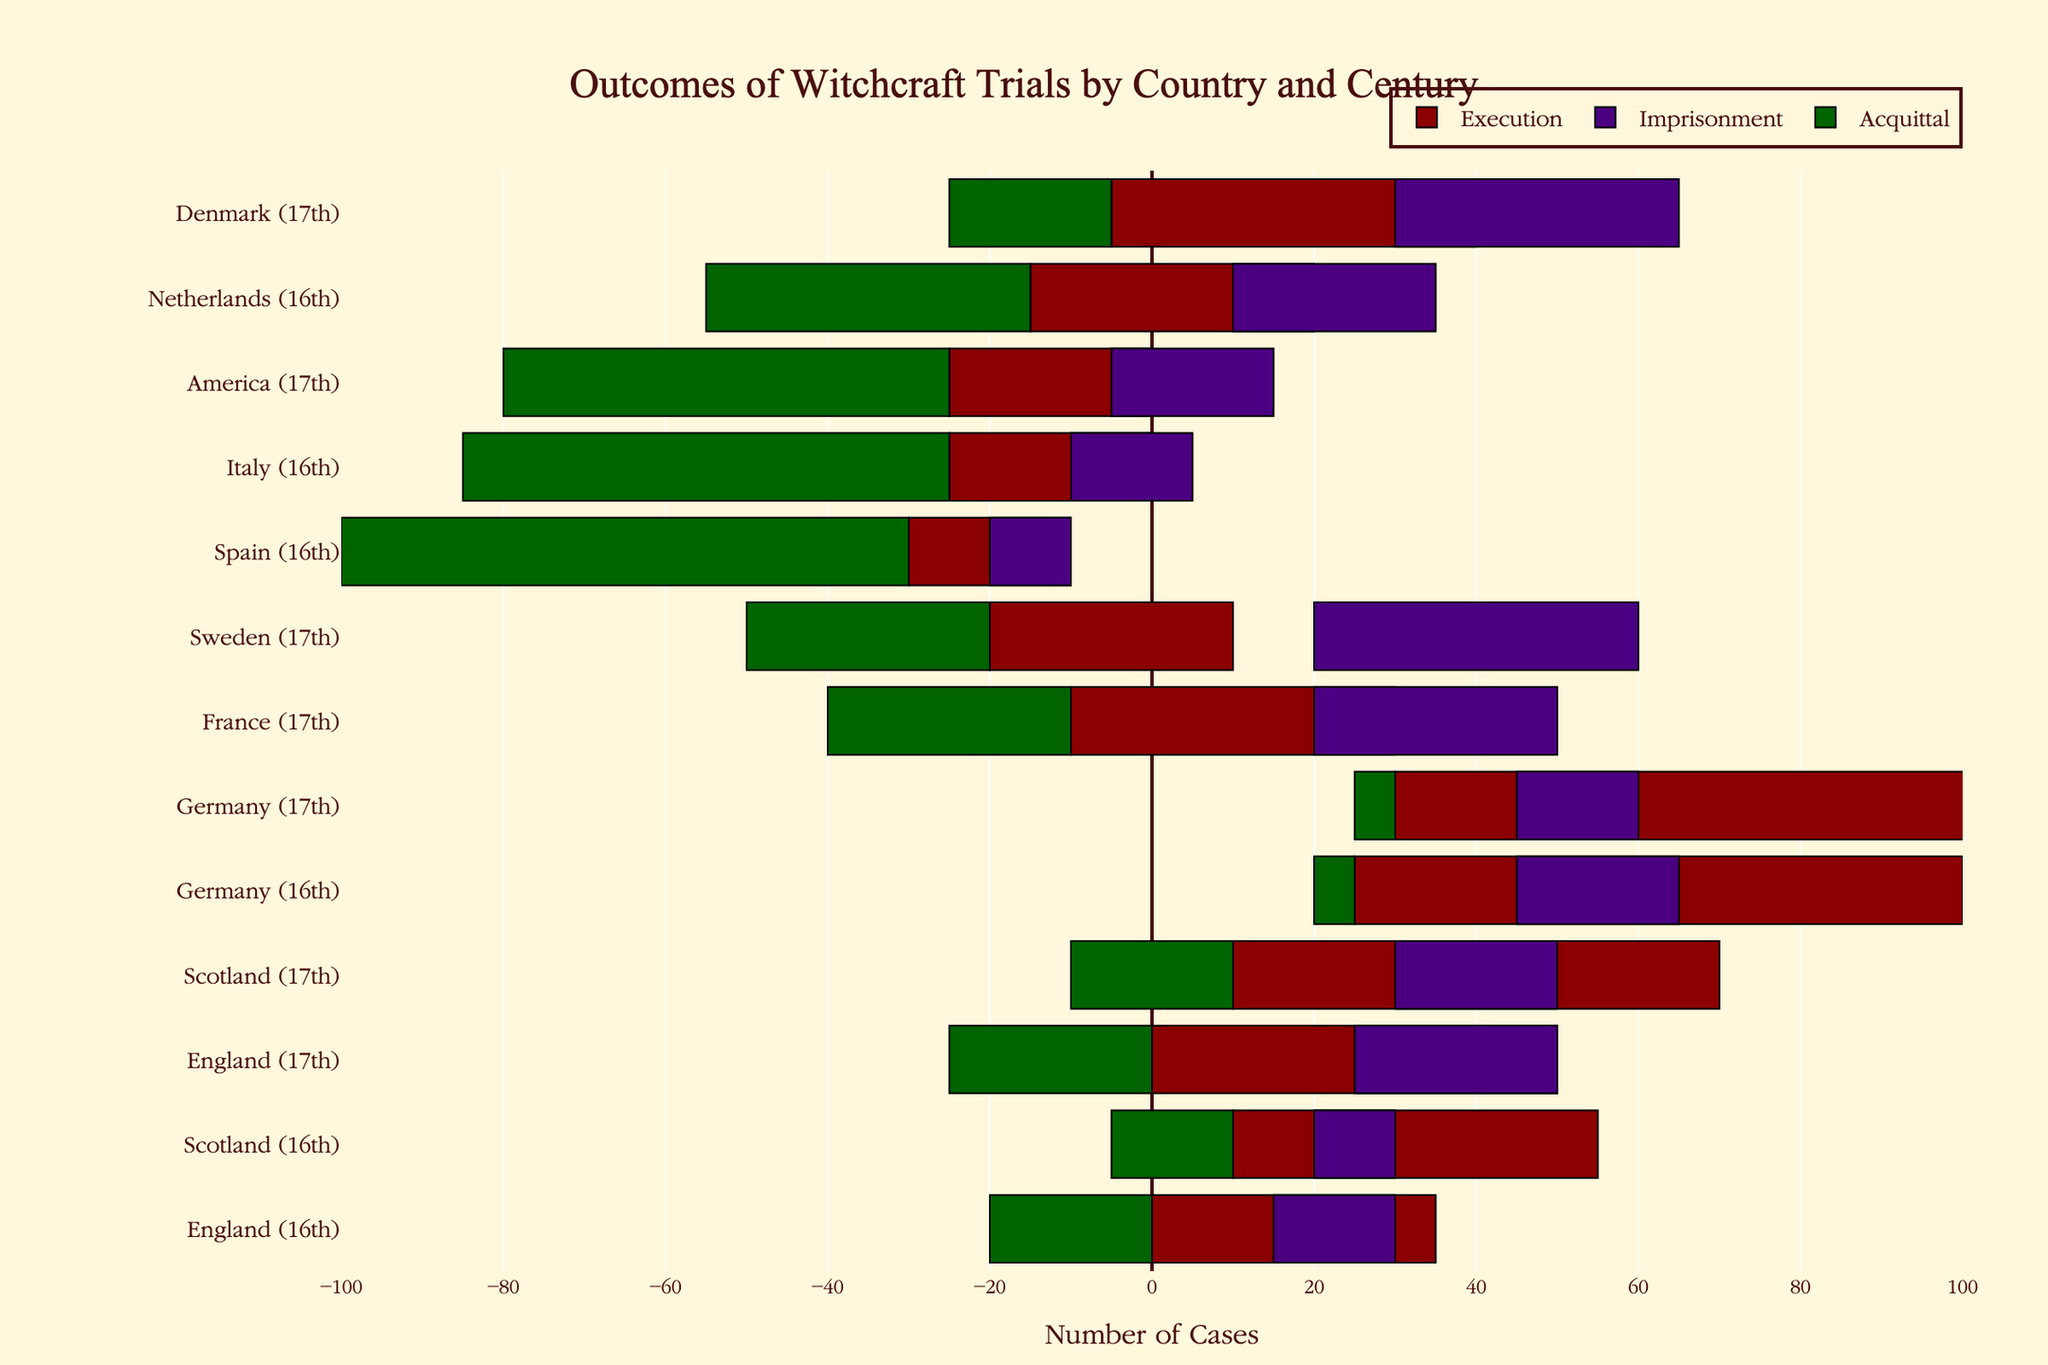Which country in the 16th century had the highest number of executions? By visually comparing the lengths of the bars for all countries in the 16th century, we see that Germany has the longest red bar, indicating the highest number of executions.
Answer: Germany How many total cases (sum of executions, imprisonments, and acquittals) were there in America in the 17th century? The total number of cases is the sum of executions, imprisonments, and acquittals. For America: 25 (executions) + 20 (imprisonments) + 55 (acquittals) = 100.
Answer: 100 Which country had the least number of executions in the 17th century? By comparing the red bars for the 17th century entries, Sweden has the shortest bar for executions.
Answer: Sweden In comparison, did England in the 16th century have more acquittals than executions? For England in the 16th century, the length of the green bar (acquittals) is shorter than the red bar (executions). Thus, there were fewer acquittals compared to executions.
Answer: No What is the difference in the number of imprisonments between France and Sweden in the 17th century? Subtract the length of the purple bar for Sweden (40) from the length of the purple bar for France (30). The difference is 40 - 30 = 10.
Answer: 10 Which country had the highest number of acquittals in the 16th century? By comparing the length of the green bars for the 16th century entries, Spain has the longest bar, indicating the highest number of acquittals.
Answer: Spain How many more executions occurred in Germany compared to Scotland in the 17th century? The length of the red bar for Germany in the 17th century is 80, and for Scotland, it is 60. The difference is 80 - 60 = 20.
Answer: 20 What proportion of total cases in 16th century Denmark were executions? Denmark is not present in the 16th century dataset. Thus, it had zero executions in the 16th century.
Answer: 0 Did more people get imprisoned in France or Denmark in the 17th century? By comparing the purple bars for France and Denmark in the 17th century, Denmark has a longer bar, indicating more imprisonments.
Answer: Denmark 